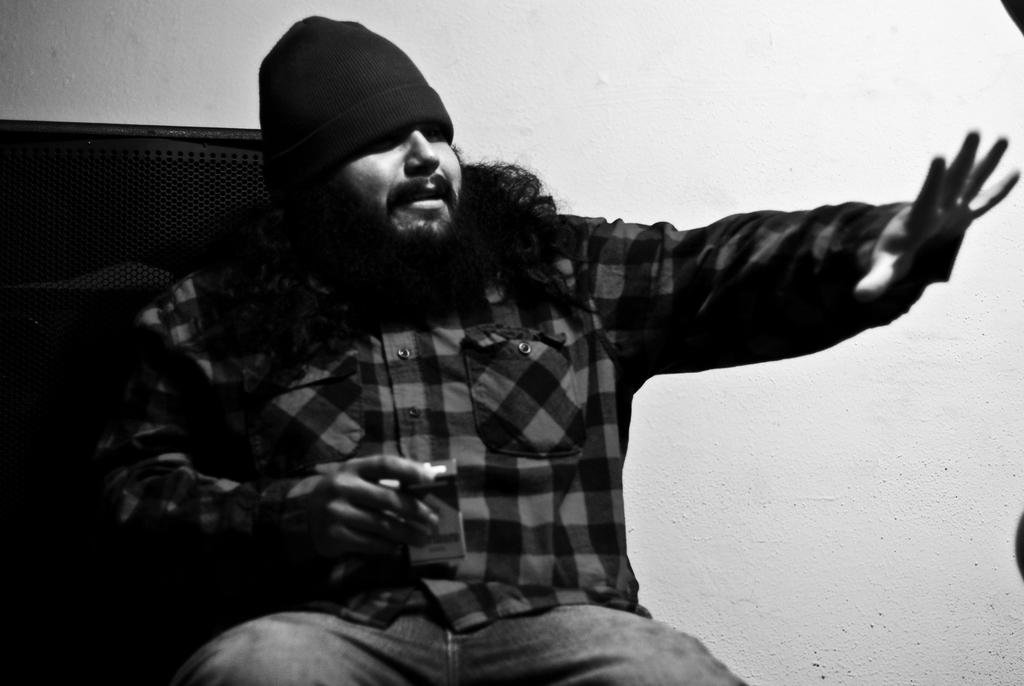Who is present in the image? There is a man in the image. What is the man doing in the image? The man is sitting on a couch. What object is the man holding in the image? The man is holding a cigarette packet. What can be seen behind the man in the image? There is a wall behind the man. Can you see any goldfish swimming in the image? There are no goldfish present in the image. Is the man in the image preparing for a trip? The image does not provide any information about the man's plans for a trip. 